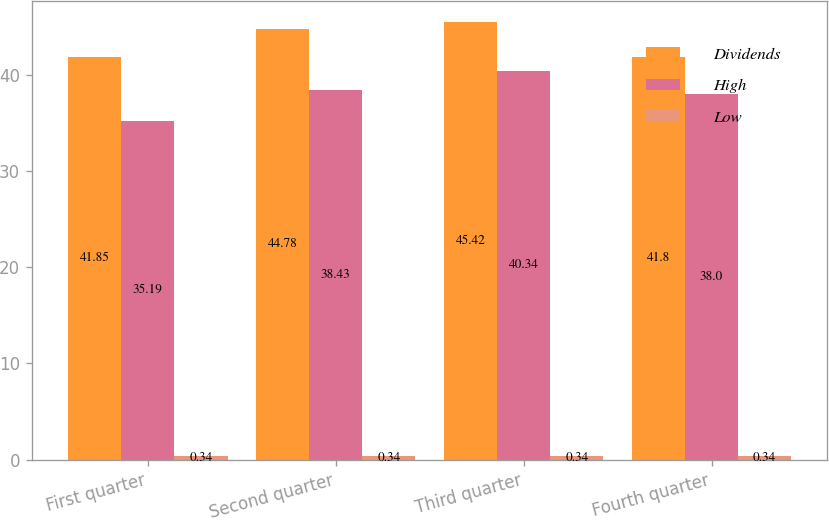Convert chart to OTSL. <chart><loc_0><loc_0><loc_500><loc_500><stacked_bar_chart><ecel><fcel>First quarter<fcel>Second quarter<fcel>Third quarter<fcel>Fourth quarter<nl><fcel>Dividends<fcel>41.85<fcel>44.78<fcel>45.42<fcel>41.8<nl><fcel>High<fcel>35.19<fcel>38.43<fcel>40.34<fcel>38<nl><fcel>Low<fcel>0.34<fcel>0.34<fcel>0.34<fcel>0.34<nl></chart> 